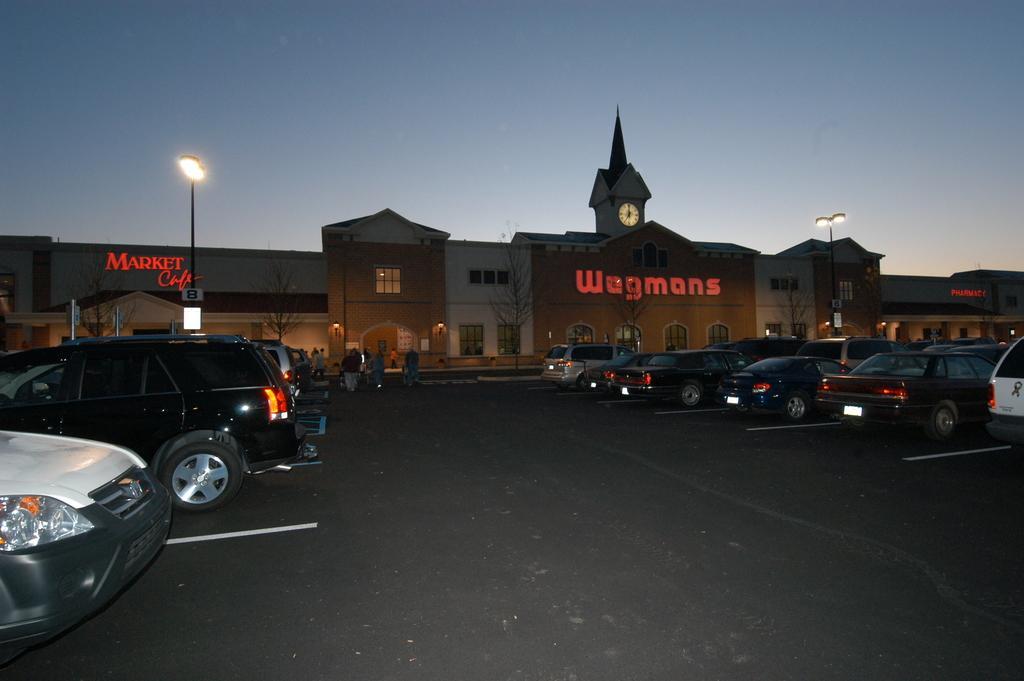Could you give a brief overview of what you see in this image? In this image we can see a building with text and a clock, there are light poles, dry trees, few people walking on the road and there are few cars parked in front of the building and there is a sky in the background. 